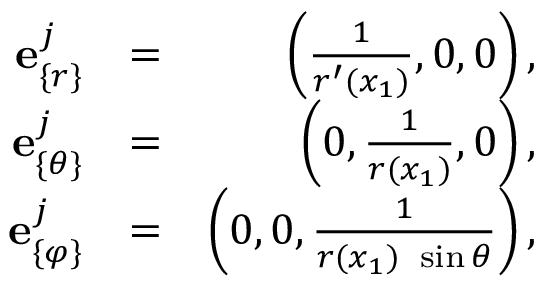<formula> <loc_0><loc_0><loc_500><loc_500>\begin{array} { r l r } { { e } _ { \{ r \} } ^ { j } } & { = } & { \left ( \frac { 1 } { r ^ { \prime } ( x _ { 1 } ) } , 0 , 0 \right ) , } \\ { { e } _ { \{ \theta \} } ^ { j } } & { = } & { \left ( 0 , \frac { 1 } { r ( x _ { 1 } ) } , 0 \right ) , } \\ { { e } _ { \{ \varphi \} } ^ { j } } & { = } & { \left ( 0 , 0 , \frac { 1 } { r ( x _ { 1 } ) \ \sin \theta } \right ) , } \end{array}</formula> 